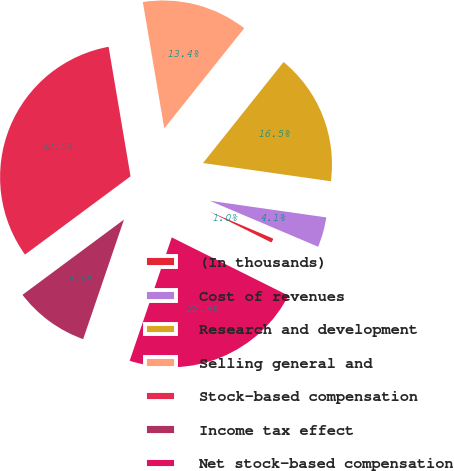<chart> <loc_0><loc_0><loc_500><loc_500><pie_chart><fcel>(In thousands)<fcel>Cost of revenues<fcel>Research and development<fcel>Selling general and<fcel>Stock-based compensation<fcel>Income tax effect<fcel>Net stock-based compensation<nl><fcel>0.98%<fcel>4.13%<fcel>16.54%<fcel>13.39%<fcel>32.48%<fcel>9.61%<fcel>22.87%<nl></chart> 